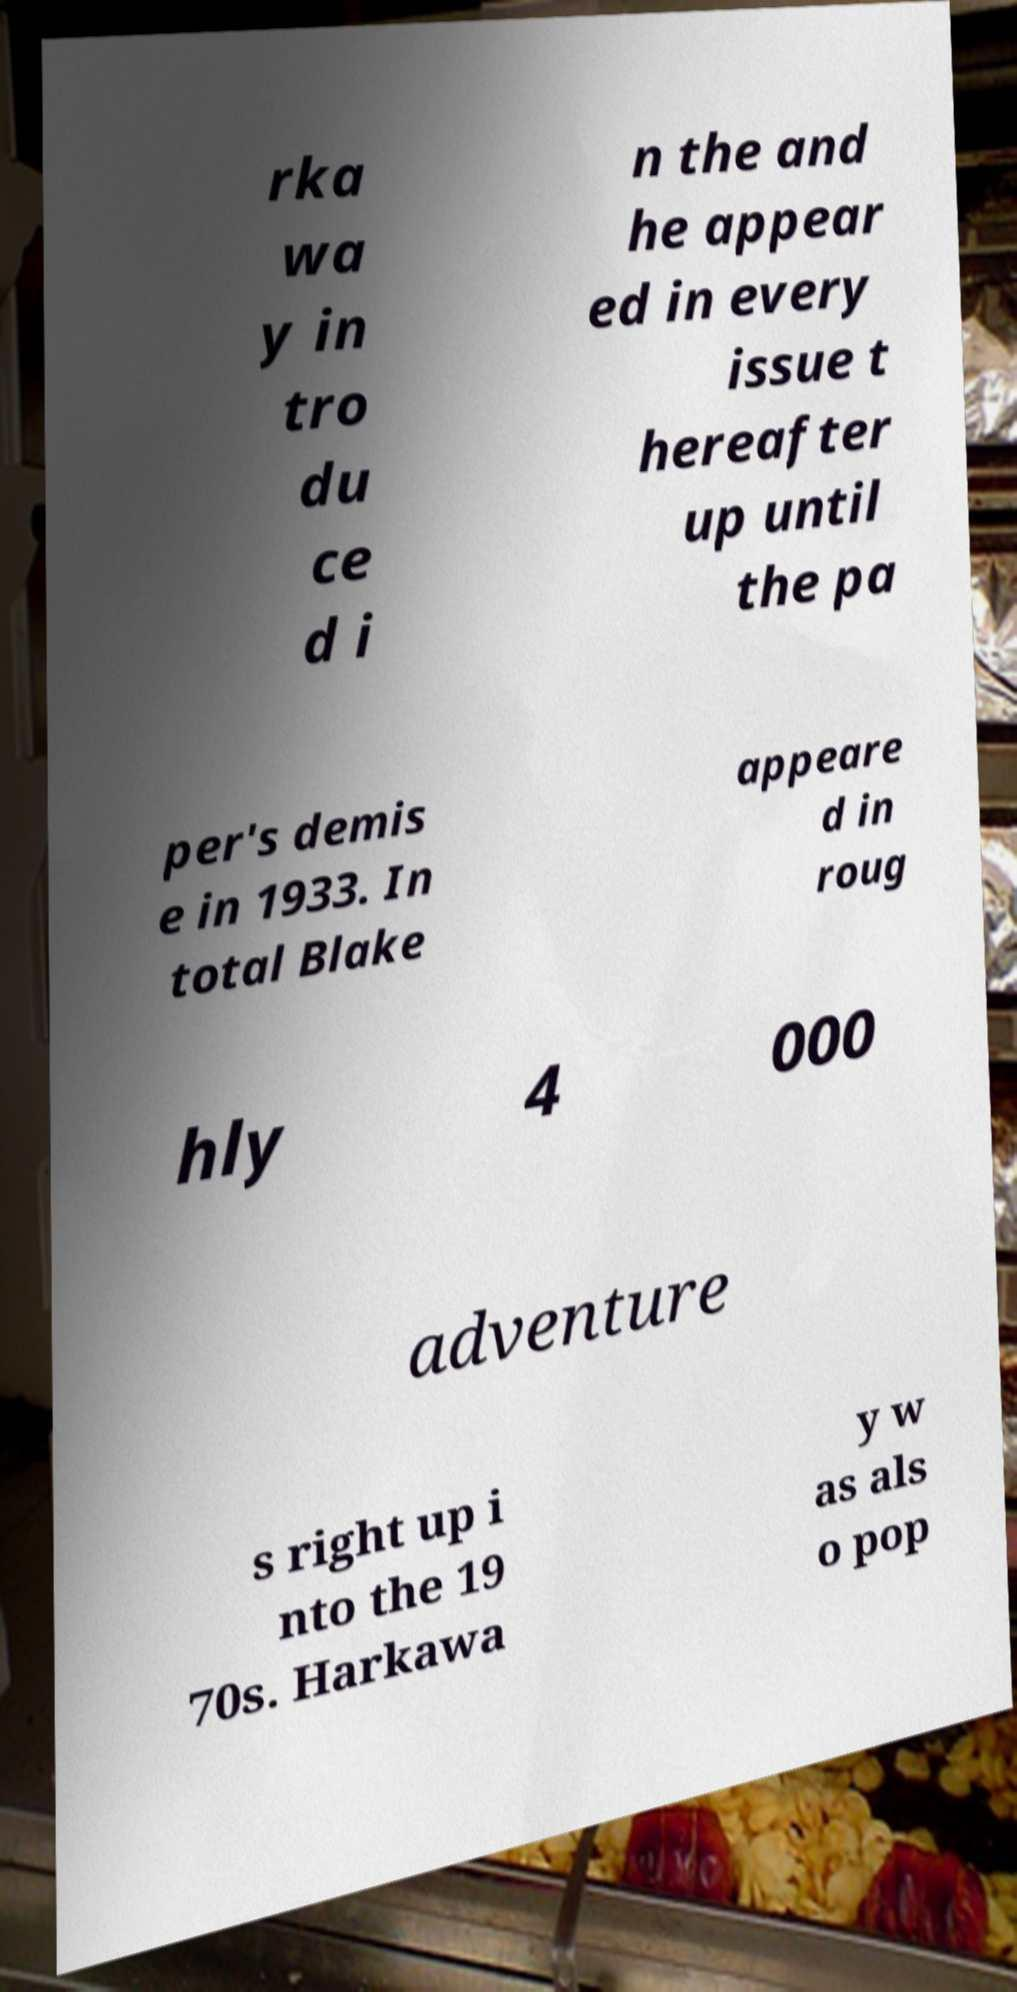Please read and relay the text visible in this image. What does it say? rka wa y in tro du ce d i n the and he appear ed in every issue t hereafter up until the pa per's demis e in 1933. In total Blake appeare d in roug hly 4 000 adventure s right up i nto the 19 70s. Harkawa y w as als o pop 